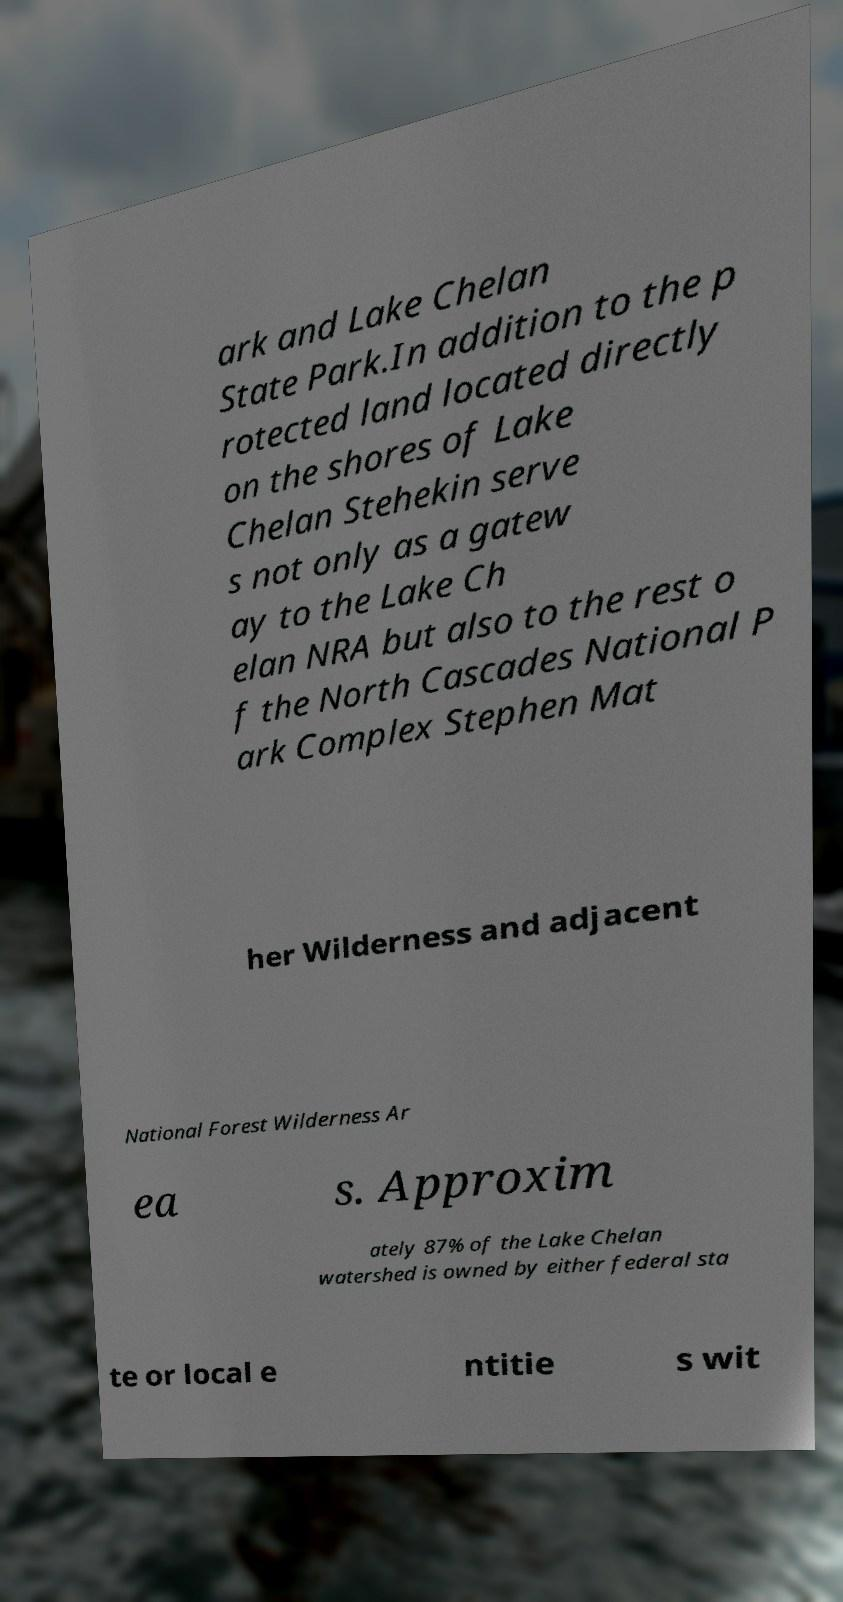Can you read and provide the text displayed in the image?This photo seems to have some interesting text. Can you extract and type it out for me? ark and Lake Chelan State Park.In addition to the p rotected land located directly on the shores of Lake Chelan Stehekin serve s not only as a gatew ay to the Lake Ch elan NRA but also to the rest o f the North Cascades National P ark Complex Stephen Mat her Wilderness and adjacent National Forest Wilderness Ar ea s. Approxim ately 87% of the Lake Chelan watershed is owned by either federal sta te or local e ntitie s wit 